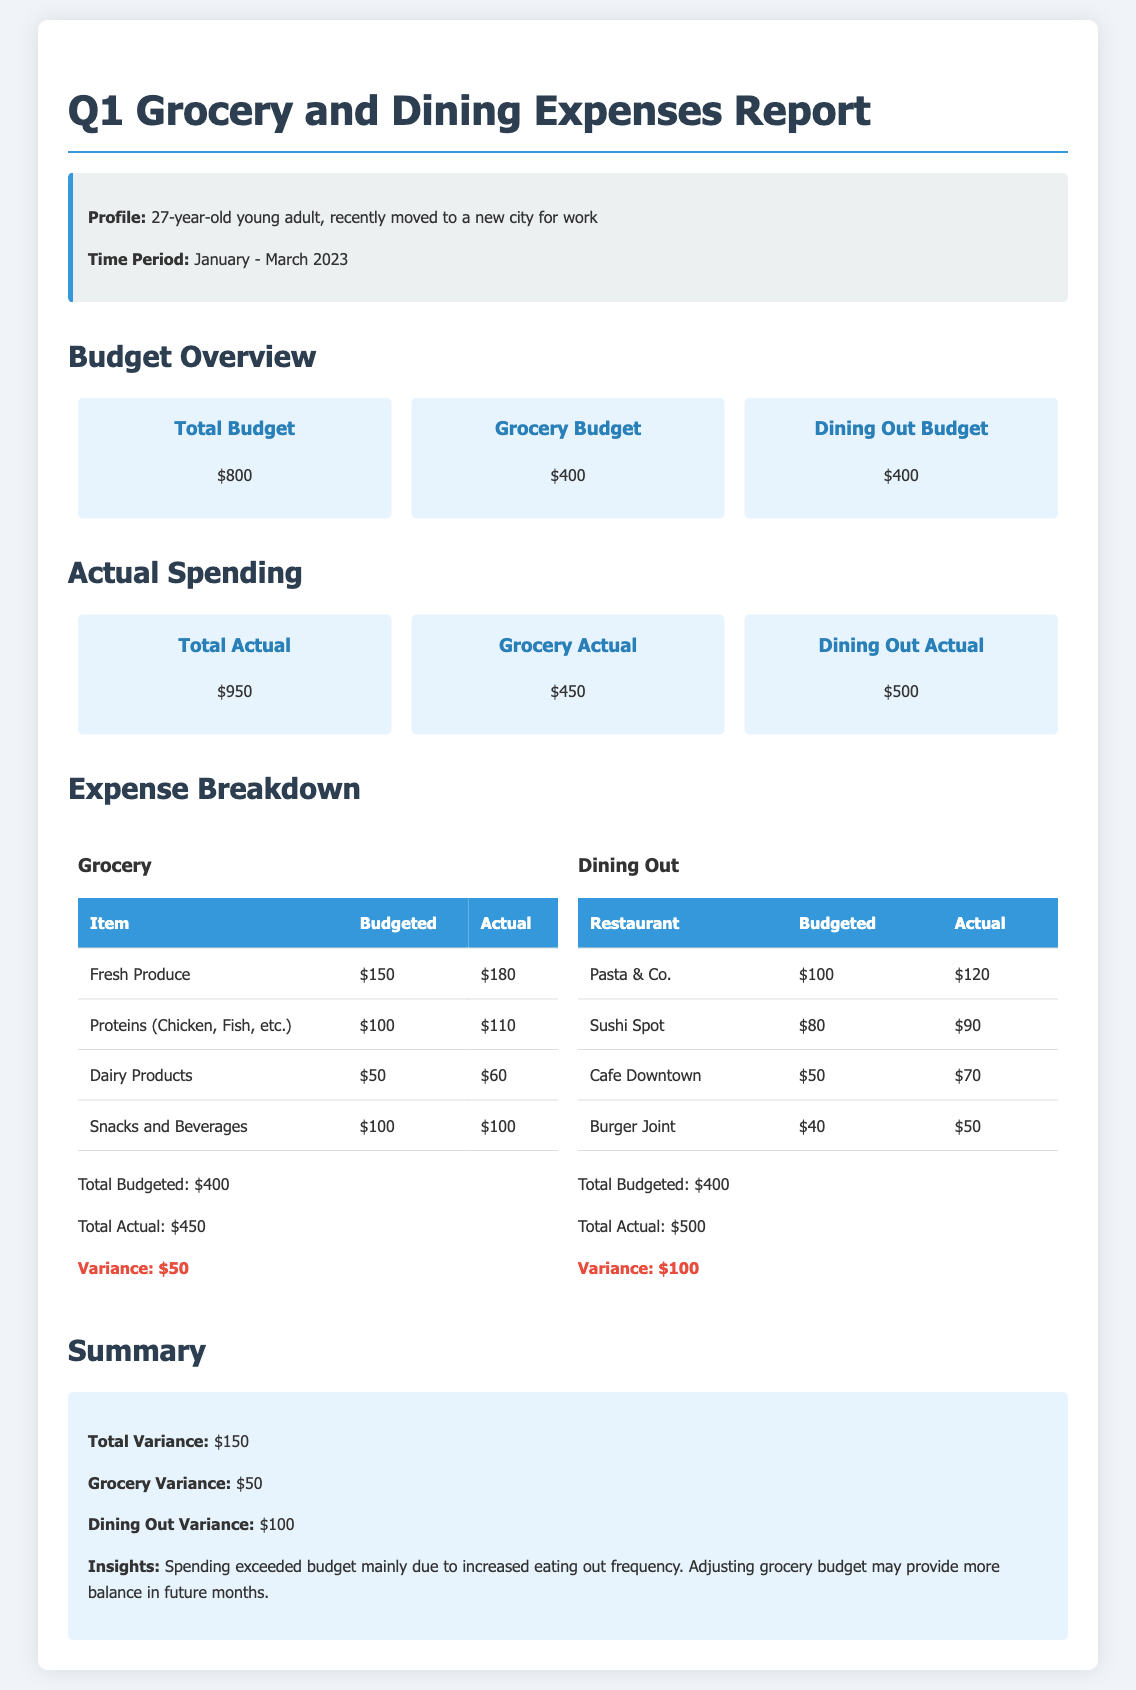What is the total budget for the first quarter? The total budget is specified in the document as $800.
Answer: $800 How much was spent on groceries? The actual spending on groceries is detailed in the report as $450.
Answer: $450 What is the variance for dining out expenses? The variance for dining out can be found by comparing the budgeted and actual amounts, which is $100.
Answer: $100 What is the total actual spending for the first quarter? The document states the total actual spending is $950.
Answer: $950 What was budgeted for fresh produce? The budgeted amount for fresh produce is mentioned as $150.
Answer: $150 How much was actually spent at Cafe Downtown? The report indicates the actual spending at Cafe Downtown as $70.
Answer: $70 What was the primary reason for the total variance? The insights section highlights that the spending exceeded budget mainly due to increased eating out frequency.
Answer: Increased eating out frequency What is the total budgeted amount for dining out? The total budget for dining out is specifically shown as $400.
Answer: $400 What was the total variance across all expenses? The total variance is summarized in the document as $150.
Answer: $150 